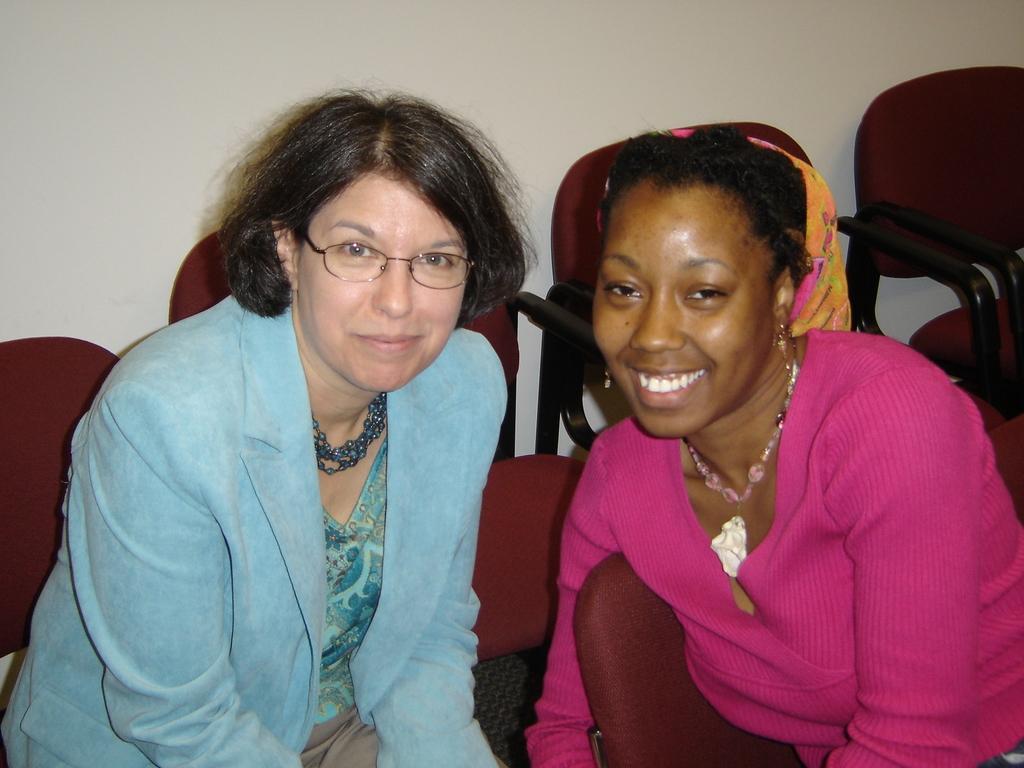Can you describe this image briefly? In this image we can see two women sitting. And we can see the chairs and the wall. 